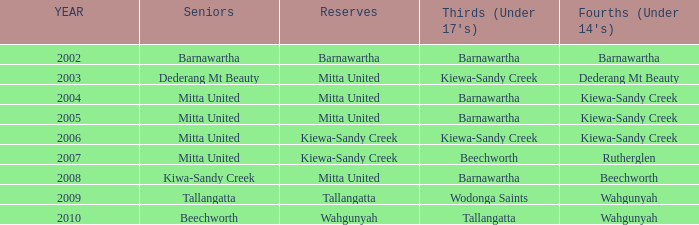Which Fourths (Under 14's) have Seniors of dederang mt beauty? Dederang Mt Beauty. 